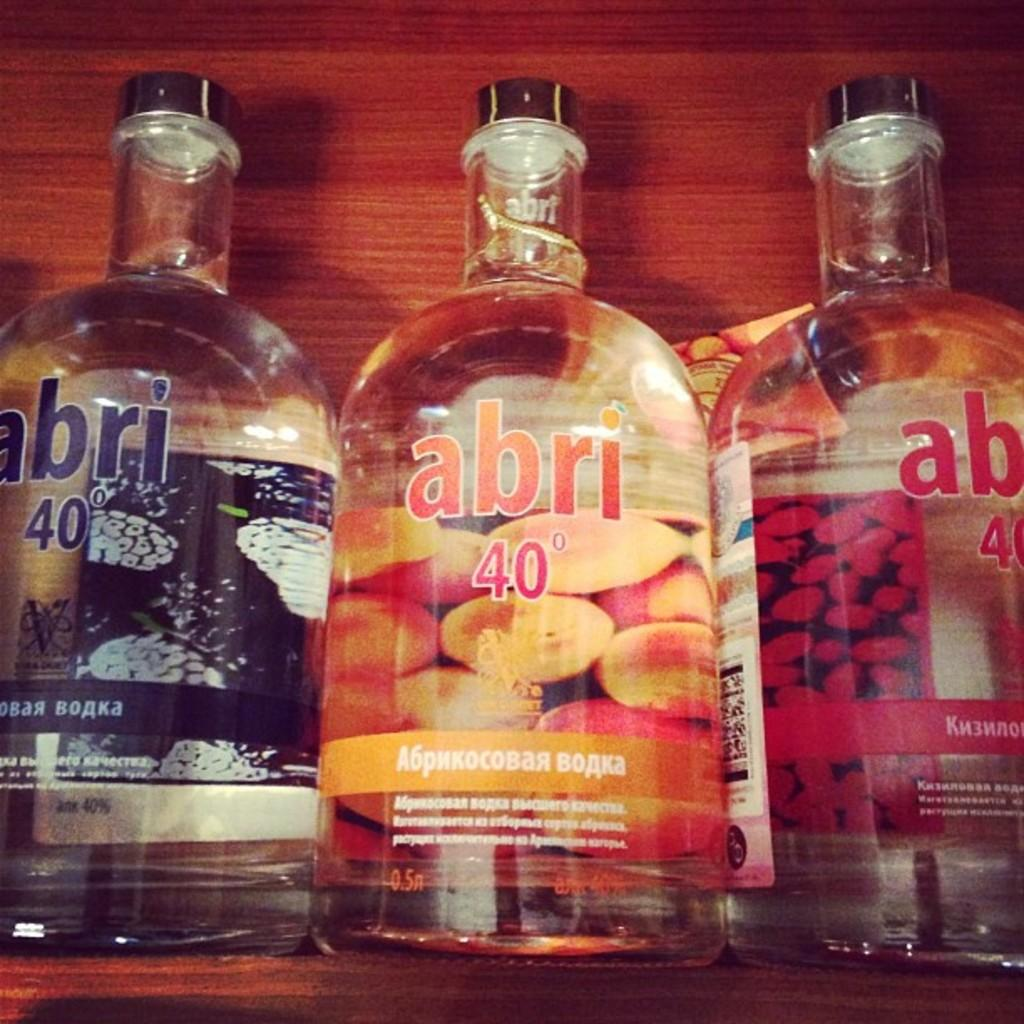Provide a one-sentence caption for the provided image. three different colored bottles of clear liquor by abri. 